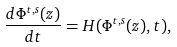Convert formula to latex. <formula><loc_0><loc_0><loc_500><loc_500>\frac { d \Phi ^ { t , s } ( z ) } { d t } = H ( \Phi ^ { t , s } ( z ) , t ) ,</formula> 